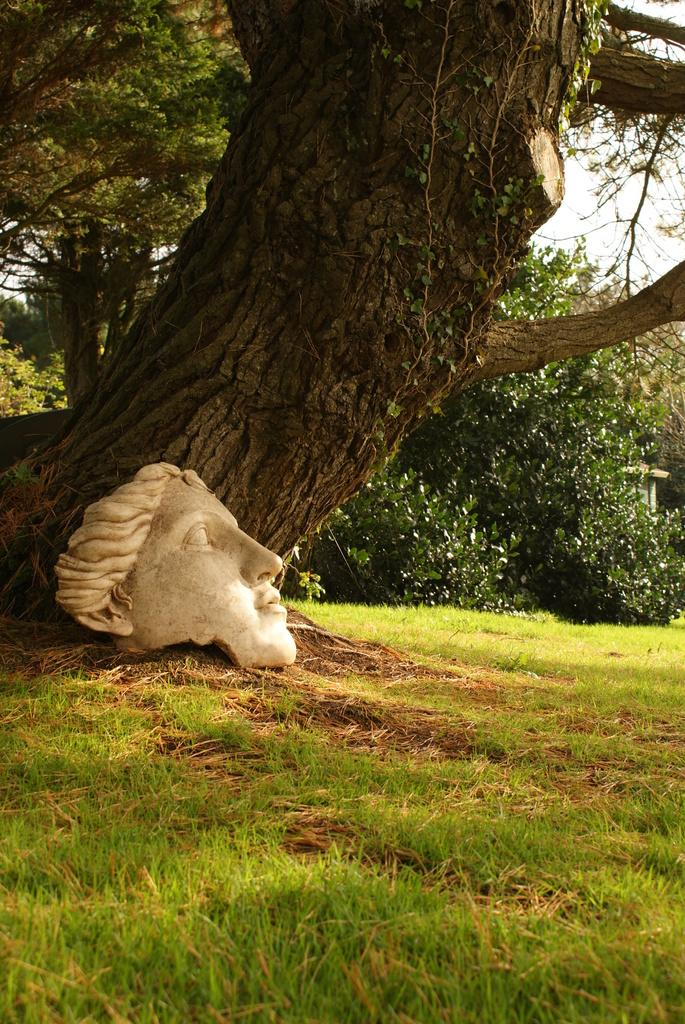What is the main subject in the center of the image? There is a tree in the center of the image. What other objects can be seen in the image? There is a sculpture in the image. What type of ground is visible at the bottom of the image? There is grass at the bottom of the image. What can be seen in the background of the image? There are trees and the sky visible in the background of the image. What type of wristwatch is the tree wearing in the image? There is no wristwatch present on the tree in the image. What discovery was made by the sculpture in the image? There is no discovery mentioned or implied in the image; it simply features a sculpture. 